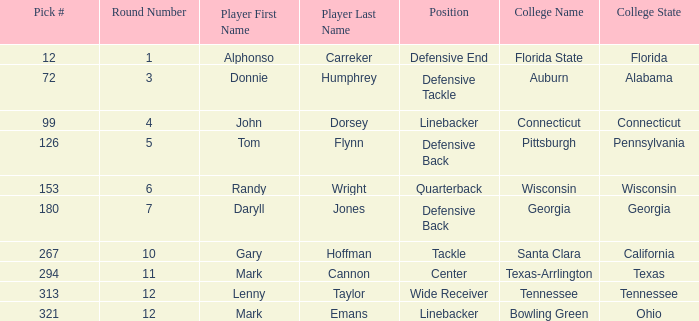In what Round was Pick #12 drafted? Round 1. 